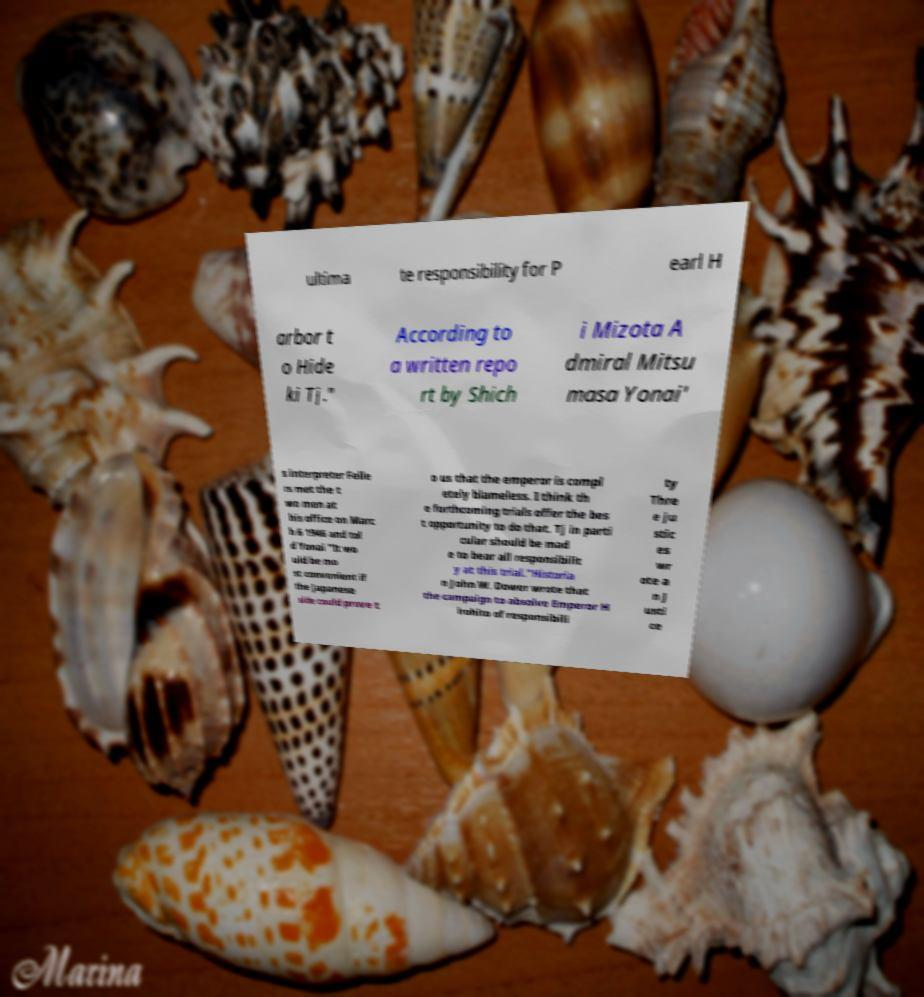I need the written content from this picture converted into text. Can you do that? ultima te responsibility for P earl H arbor t o Hide ki Tj." According to a written repo rt by Shich i Mizota A dmiral Mitsu masa Yonai' s interpreter Felle rs met the t wo men at his office on Marc h 6 1946 and tol d Yonai "It wo uld be mo st convenient if the Japanese side could prove t o us that the emperor is compl etely blameless. I think th e forthcoming trials offer the bes t opportunity to do that. Tj in parti cular should be mad e to bear all responsibilit y at this trial."Historia n John W. Dower wrote that the campaign to absolve Emperor H irohito of responsibili ty Thre e ju stic es wr ote a n J usti ce 